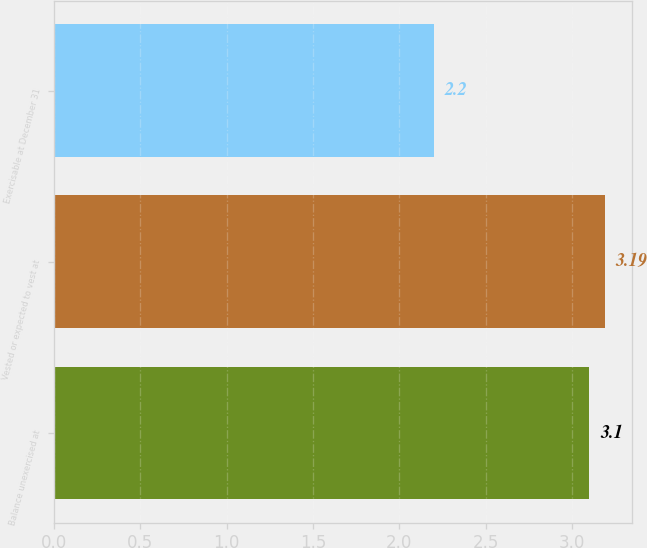<chart> <loc_0><loc_0><loc_500><loc_500><bar_chart><fcel>Balance unexercised at<fcel>Vested or expected to vest at<fcel>Exercisable at December 31<nl><fcel>3.1<fcel>3.19<fcel>2.2<nl></chart> 